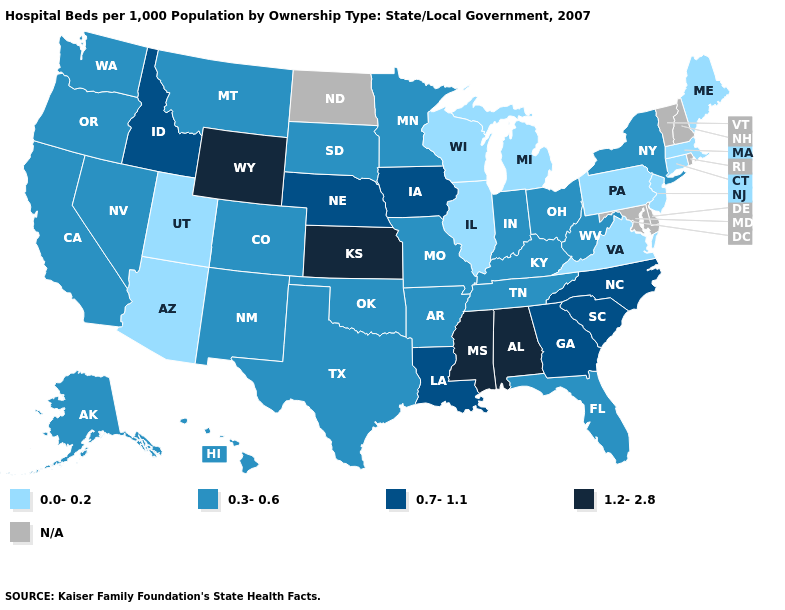Name the states that have a value in the range 0.0-0.2?
Short answer required. Arizona, Connecticut, Illinois, Maine, Massachusetts, Michigan, New Jersey, Pennsylvania, Utah, Virginia, Wisconsin. What is the value of Kentucky?
Concise answer only. 0.3-0.6. Among the states that border Arizona , which have the highest value?
Concise answer only. California, Colorado, Nevada, New Mexico. Does the first symbol in the legend represent the smallest category?
Be succinct. Yes. What is the value of South Dakota?
Quick response, please. 0.3-0.6. Which states hav the highest value in the MidWest?
Concise answer only. Kansas. Does the first symbol in the legend represent the smallest category?
Give a very brief answer. Yes. What is the lowest value in the USA?
Write a very short answer. 0.0-0.2. What is the value of Vermont?
Give a very brief answer. N/A. Among the states that border Vermont , does Massachusetts have the lowest value?
Be succinct. Yes. What is the value of Mississippi?
Give a very brief answer. 1.2-2.8. Is the legend a continuous bar?
Concise answer only. No. Does Alabama have the lowest value in the South?
Give a very brief answer. No. What is the value of Nebraska?
Concise answer only. 0.7-1.1. What is the value of Mississippi?
Be succinct. 1.2-2.8. 